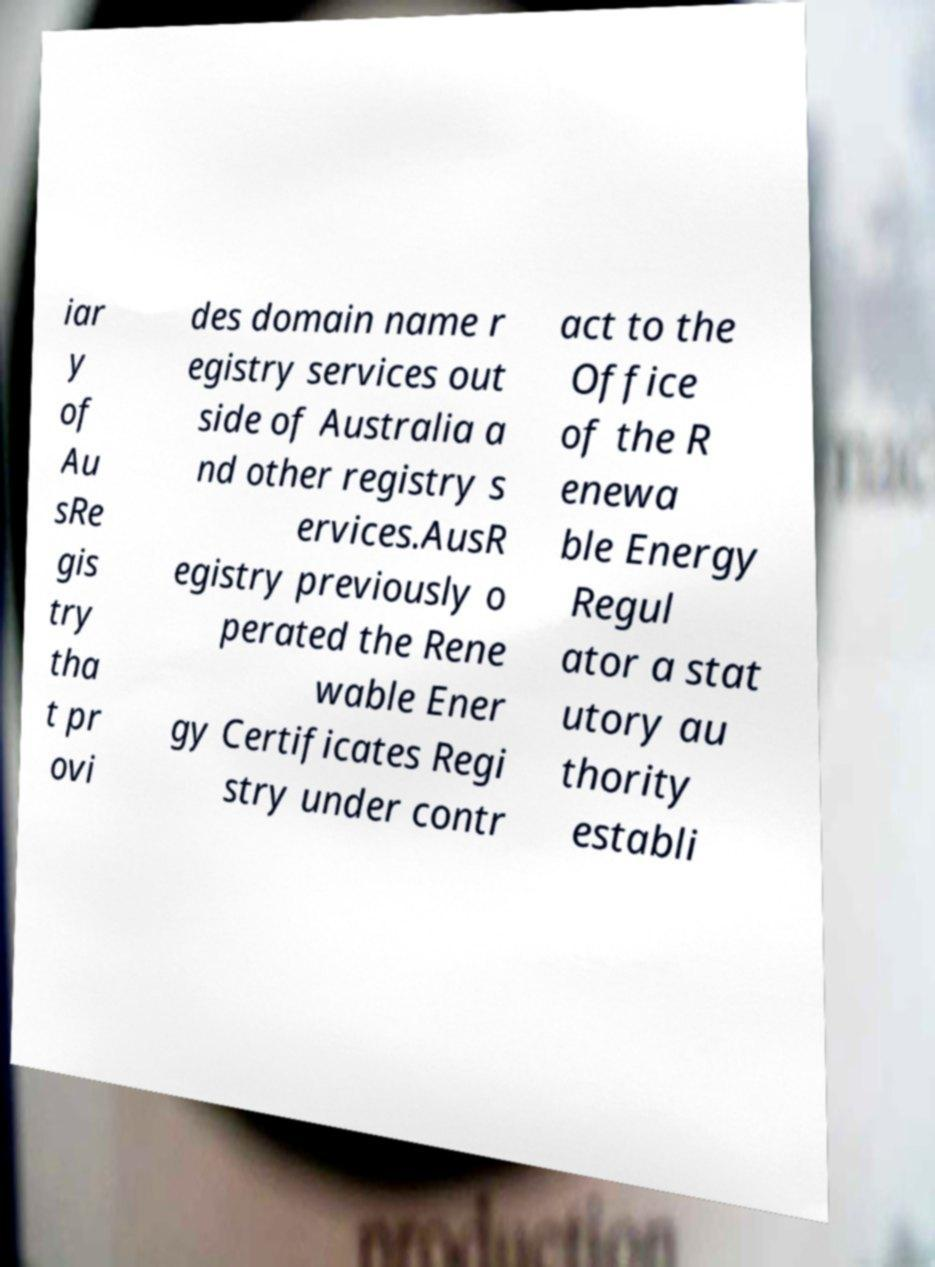There's text embedded in this image that I need extracted. Can you transcribe it verbatim? iar y of Au sRe gis try tha t pr ovi des domain name r egistry services out side of Australia a nd other registry s ervices.AusR egistry previously o perated the Rene wable Ener gy Certificates Regi stry under contr act to the Office of the R enewa ble Energy Regul ator a stat utory au thority establi 